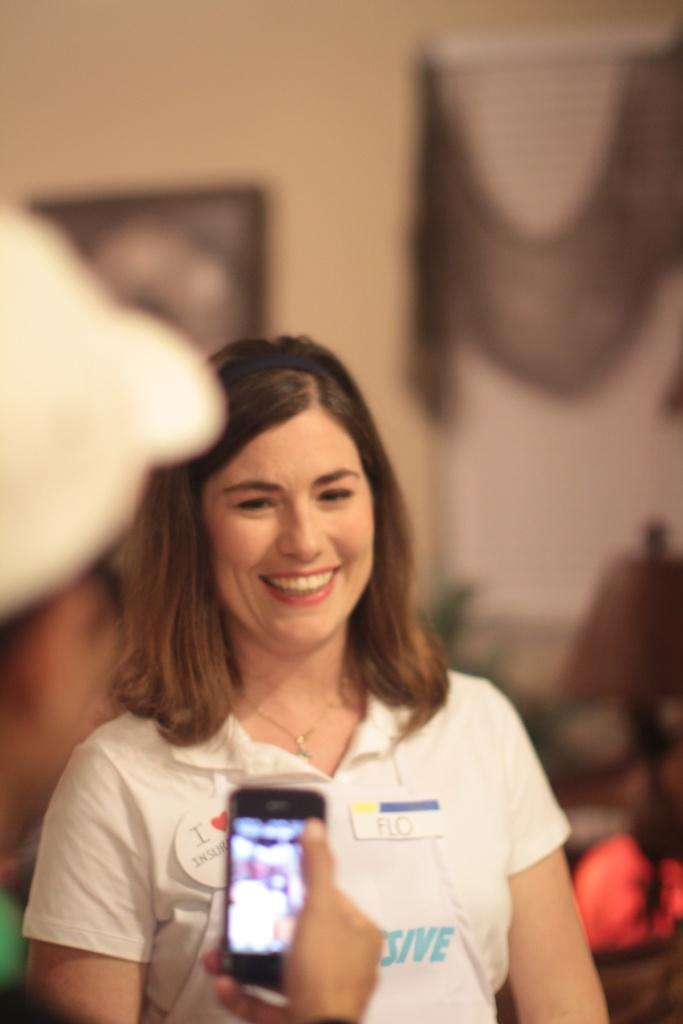Who is the main subject in the image? There is a woman in the image. What is the woman doing in the image? The woman is laughing. Who is capturing the moment in the image? There is a person taking a picture of the woman with a mobile phone. Can you describe the background of the image? The background of the woman is blurred. What type of roll can be seen in the image? There is no roll present in the image. How does the woman feel about being in quicksand in the image? There is no quicksand present in the image, and therefore the woman's feelings about it cannot be determined. 